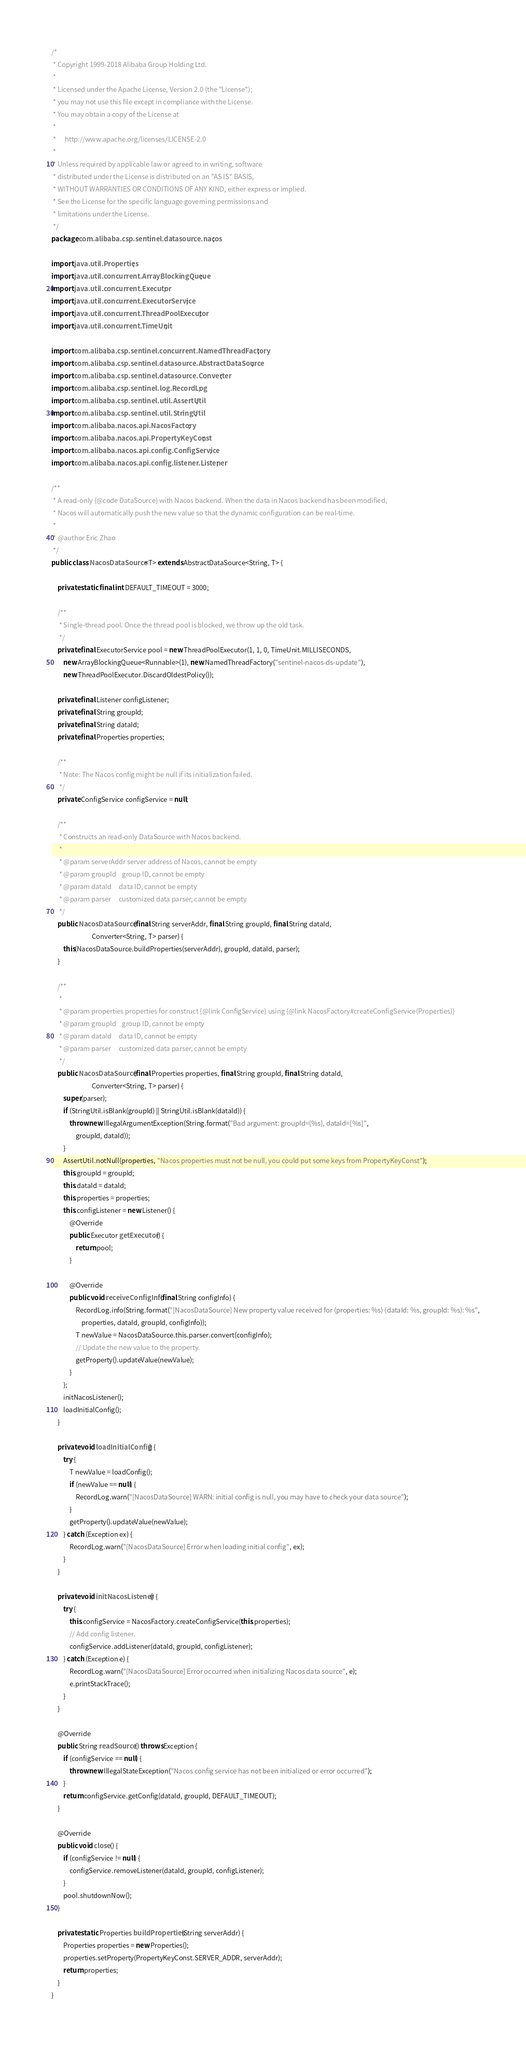Convert code to text. <code><loc_0><loc_0><loc_500><loc_500><_Java_>/*
 * Copyright 1999-2018 Alibaba Group Holding Ltd.
 *
 * Licensed under the Apache License, Version 2.0 (the "License");
 * you may not use this file except in compliance with the License.
 * You may obtain a copy of the License at
 *
 *      http://www.apache.org/licenses/LICENSE-2.0
 *
 * Unless required by applicable law or agreed to in writing, software
 * distributed under the License is distributed on an "AS IS" BASIS,
 * WITHOUT WARRANTIES OR CONDITIONS OF ANY KIND, either express or implied.
 * See the License for the specific language governing permissions and
 * limitations under the License.
 */
package com.alibaba.csp.sentinel.datasource.nacos;

import java.util.Properties;
import java.util.concurrent.ArrayBlockingQueue;
import java.util.concurrent.Executor;
import java.util.concurrent.ExecutorService;
import java.util.concurrent.ThreadPoolExecutor;
import java.util.concurrent.TimeUnit;

import com.alibaba.csp.sentinel.concurrent.NamedThreadFactory;
import com.alibaba.csp.sentinel.datasource.AbstractDataSource;
import com.alibaba.csp.sentinel.datasource.Converter;
import com.alibaba.csp.sentinel.log.RecordLog;
import com.alibaba.csp.sentinel.util.AssertUtil;
import com.alibaba.csp.sentinel.util.StringUtil;
import com.alibaba.nacos.api.NacosFactory;
import com.alibaba.nacos.api.PropertyKeyConst;
import com.alibaba.nacos.api.config.ConfigService;
import com.alibaba.nacos.api.config.listener.Listener;

/**
 * A read-only {@code DataSource} with Nacos backend. When the data in Nacos backend has been modified,
 * Nacos will automatically push the new value so that the dynamic configuration can be real-time.
 *
 * @author Eric Zhao
 */
public class NacosDataSource<T> extends AbstractDataSource<String, T> {

    private static final int DEFAULT_TIMEOUT = 3000;

    /**
     * Single-thread pool. Once the thread pool is blocked, we throw up the old task.
     */
    private final ExecutorService pool = new ThreadPoolExecutor(1, 1, 0, TimeUnit.MILLISECONDS,
        new ArrayBlockingQueue<Runnable>(1), new NamedThreadFactory("sentinel-nacos-ds-update"),
        new ThreadPoolExecutor.DiscardOldestPolicy());

    private final Listener configListener;
    private final String groupId;
    private final String dataId;
    private final Properties properties;

    /**
     * Note: The Nacos config might be null if its initialization failed.
     */
    private ConfigService configService = null;

    /**
     * Constructs an read-only DataSource with Nacos backend.
     *
     * @param serverAddr server address of Nacos, cannot be empty
     * @param groupId    group ID, cannot be empty
     * @param dataId     data ID, cannot be empty
     * @param parser     customized data parser, cannot be empty
     */
    public NacosDataSource(final String serverAddr, final String groupId, final String dataId,
                           Converter<String, T> parser) {
        this(NacosDataSource.buildProperties(serverAddr), groupId, dataId, parser);
    }

    /**
     *
     * @param properties properties for construct {@link ConfigService} using {@link NacosFactory#createConfigService(Properties)}
     * @param groupId    group ID, cannot be empty
     * @param dataId     data ID, cannot be empty
     * @param parser     customized data parser, cannot be empty
     */
    public NacosDataSource(final Properties properties, final String groupId, final String dataId,
                           Converter<String, T> parser) {
        super(parser);
        if (StringUtil.isBlank(groupId) || StringUtil.isBlank(dataId)) {
            throw new IllegalArgumentException(String.format("Bad argument: groupId=[%s], dataId=[%s]",
                groupId, dataId));
        }
        AssertUtil.notNull(properties, "Nacos properties must not be null, you could put some keys from PropertyKeyConst");
        this.groupId = groupId;
        this.dataId = dataId;
        this.properties = properties;
        this.configListener = new Listener() {
            @Override
            public Executor getExecutor() {
                return pool;
            }

            @Override
            public void receiveConfigInfo(final String configInfo) {
                RecordLog.info(String.format("[NacosDataSource] New property value received for (properties: %s) (dataId: %s, groupId: %s): %s",
                    properties, dataId, groupId, configInfo));
                T newValue = NacosDataSource.this.parser.convert(configInfo);
                // Update the new value to the property.
                getProperty().updateValue(newValue);
            }
        };
        initNacosListener();
        loadInitialConfig();
    }

    private void loadInitialConfig() {
        try {
            T newValue = loadConfig();
            if (newValue == null) {
                RecordLog.warn("[NacosDataSource] WARN: initial config is null, you may have to check your data source");
            }
            getProperty().updateValue(newValue);
        } catch (Exception ex) {
            RecordLog.warn("[NacosDataSource] Error when loading initial config", ex);
        }
    }

    private void initNacosListener() {
        try {
            this.configService = NacosFactory.createConfigService(this.properties);
            // Add config listener.
            configService.addListener(dataId, groupId, configListener);
        } catch (Exception e) {
            RecordLog.warn("[NacosDataSource] Error occurred when initializing Nacos data source", e);
            e.printStackTrace();
        }
    }

    @Override
    public String readSource() throws Exception {
        if (configService == null) {
            throw new IllegalStateException("Nacos config service has not been initialized or error occurred");
        }
        return configService.getConfig(dataId, groupId, DEFAULT_TIMEOUT);
    }

    @Override
    public void close() {
        if (configService != null) {
            configService.removeListener(dataId, groupId, configListener);
        }
        pool.shutdownNow();
    }

    private static Properties buildProperties(String serverAddr) {
        Properties properties = new Properties();
        properties.setProperty(PropertyKeyConst.SERVER_ADDR, serverAddr);
        return properties;
    }
}
</code> 